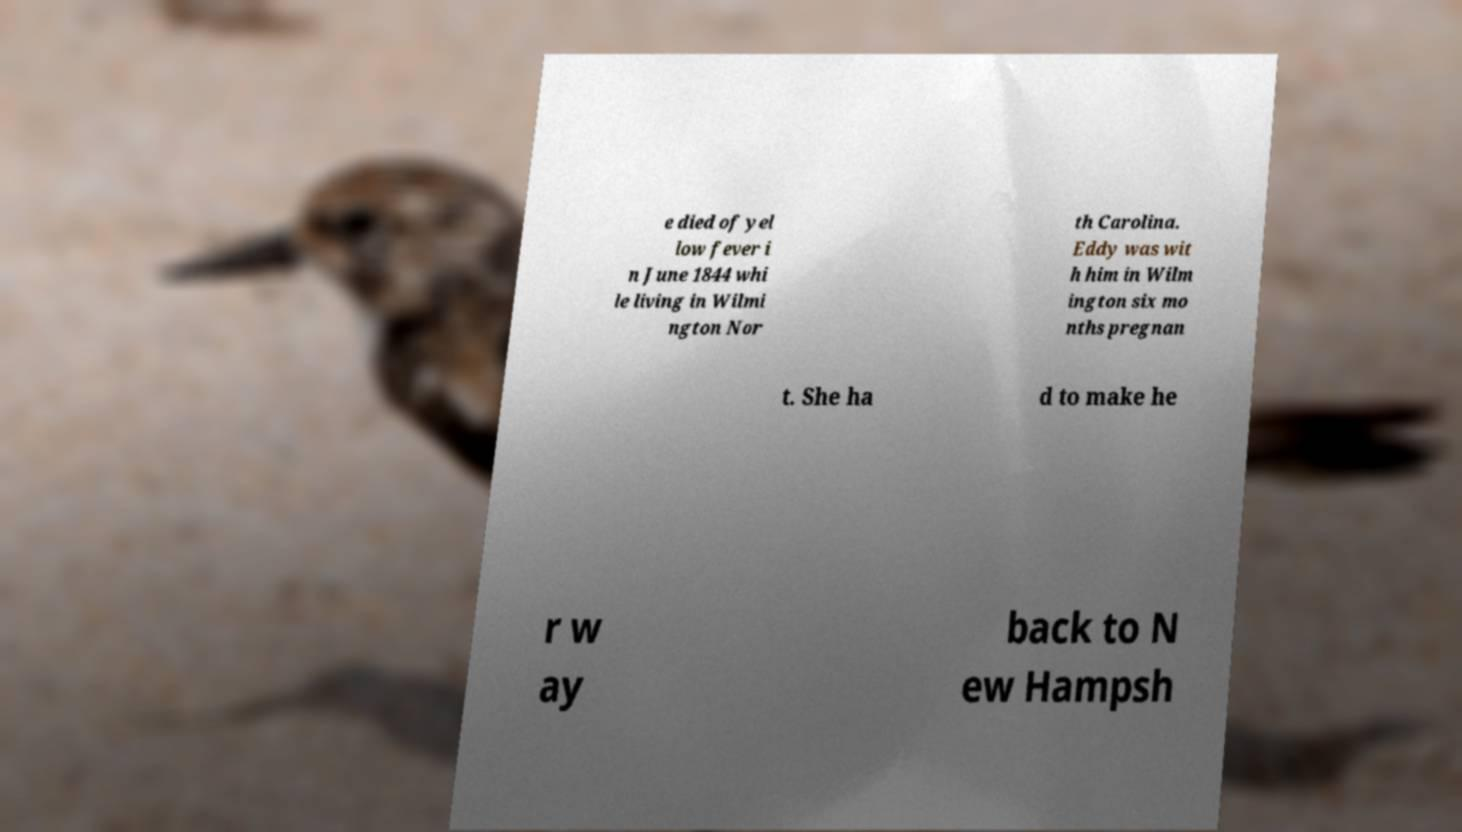I need the written content from this picture converted into text. Can you do that? e died of yel low fever i n June 1844 whi le living in Wilmi ngton Nor th Carolina. Eddy was wit h him in Wilm ington six mo nths pregnan t. She ha d to make he r w ay back to N ew Hampsh 